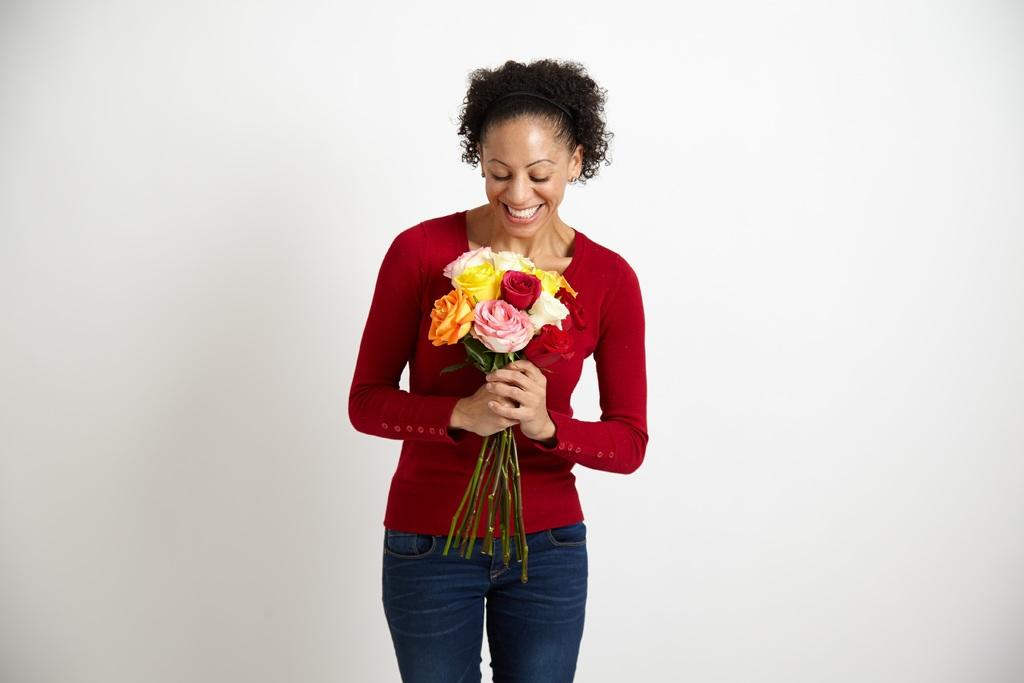Who is the main subject in the image? There is a lady in the image. What is the lady holding in the image? The lady is holding flowers. Can you describe the flowers in more detail? The flowers have stems. What is the color of the background in the image? The background of the image is white. Where is the key located in the image? There is no key present in the image. What type of rock can be seen in the image? There is no rock present in the image. 